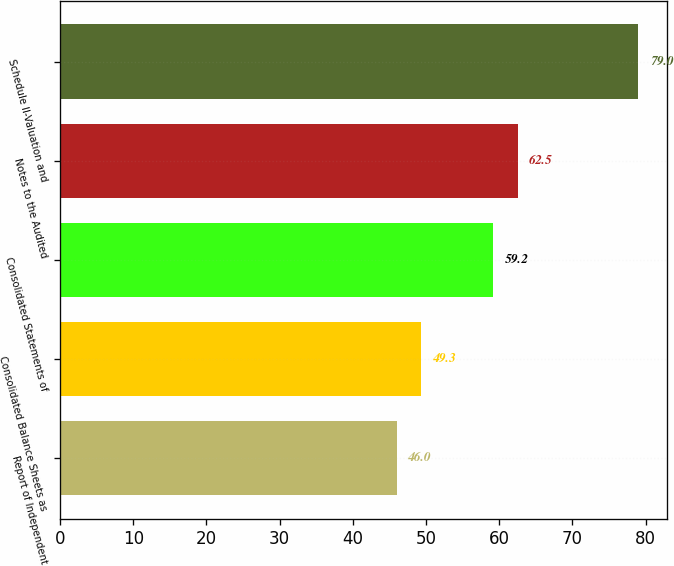Convert chart to OTSL. <chart><loc_0><loc_0><loc_500><loc_500><bar_chart><fcel>Report of Independent<fcel>Consolidated Balance Sheets as<fcel>Consolidated Statements of<fcel>Notes to the Audited<fcel>Schedule II-Valuation and<nl><fcel>46<fcel>49.3<fcel>59.2<fcel>62.5<fcel>79<nl></chart> 